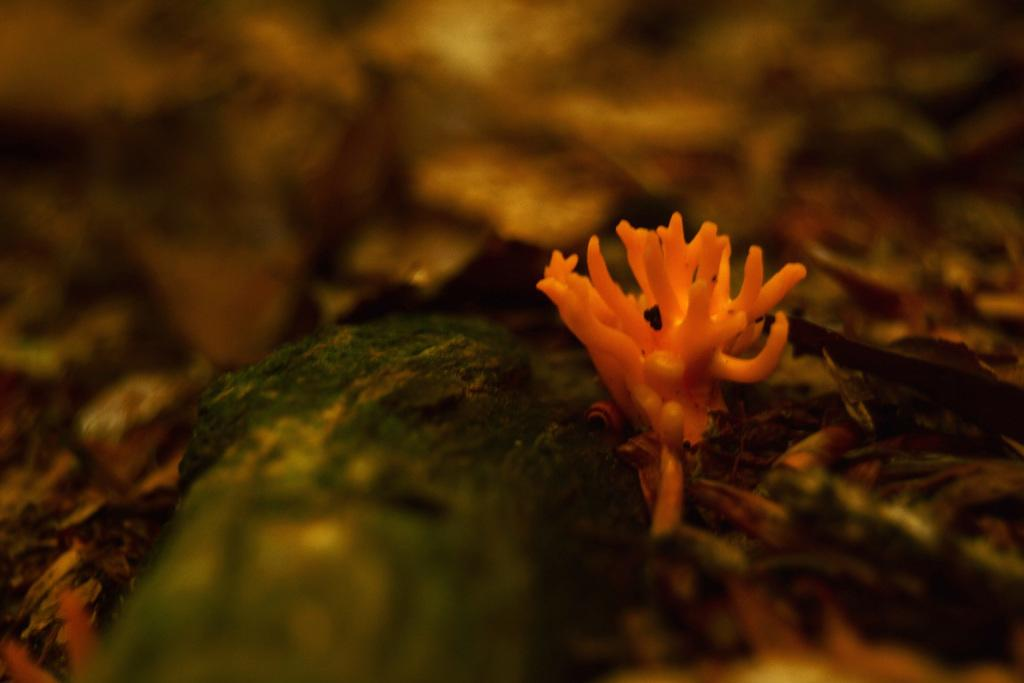What color is the main object in the image? The main object in the image is orange in color. What can be said about the background of the image? The background of the image is dark. What type of activity is the orange object engaged in within the image? The orange object is not engaged in any activity within the image, as it is an inanimate object. Can you see any writing on the orange object in the image? There is no writing visible on the orange object in the image. 